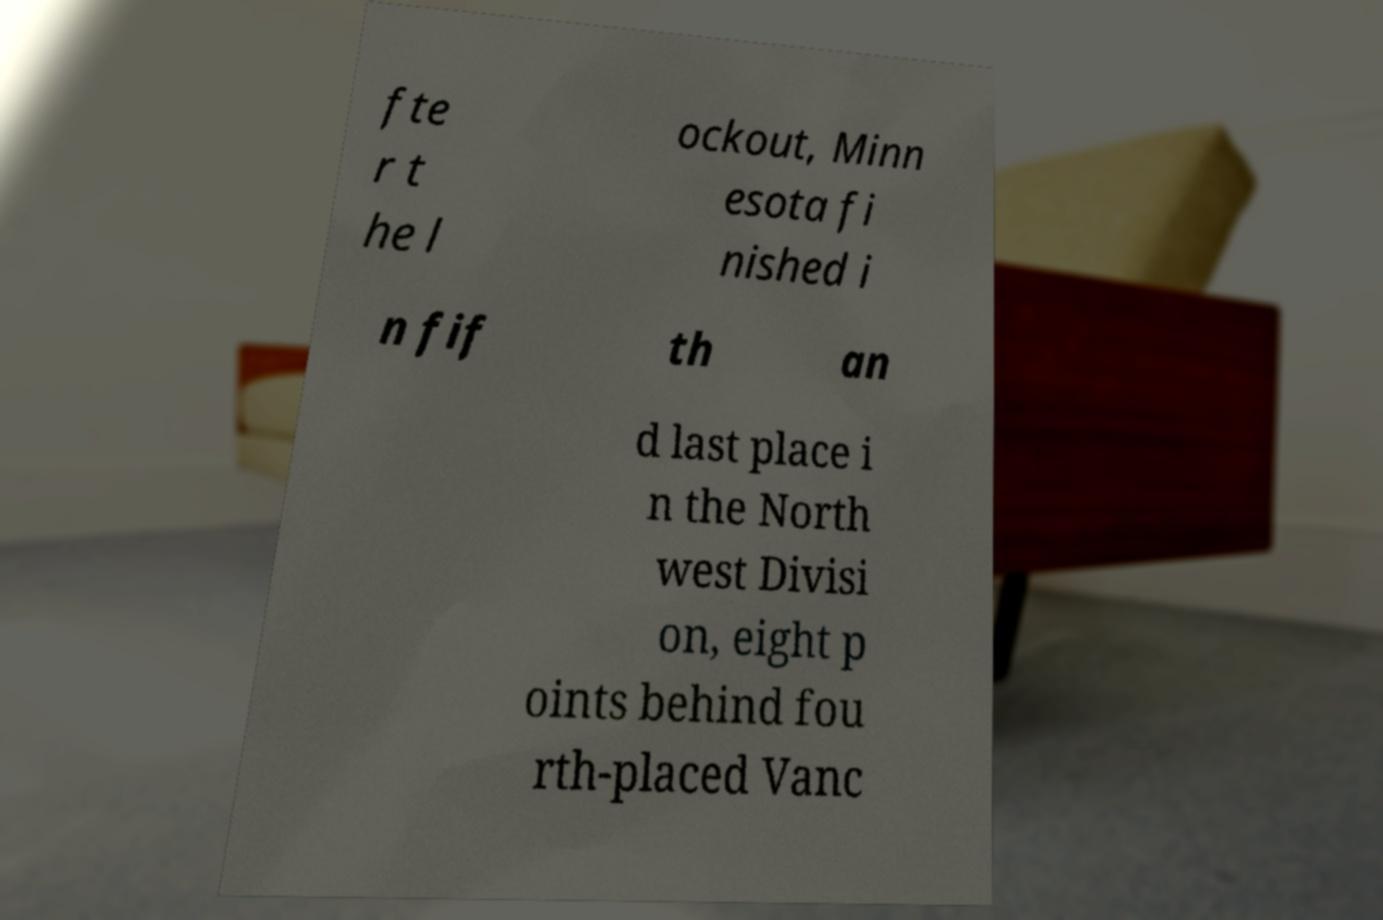For documentation purposes, I need the text within this image transcribed. Could you provide that? fte r t he l ockout, Minn esota fi nished i n fif th an d last place i n the North west Divisi on, eight p oints behind fou rth-placed Vanc 